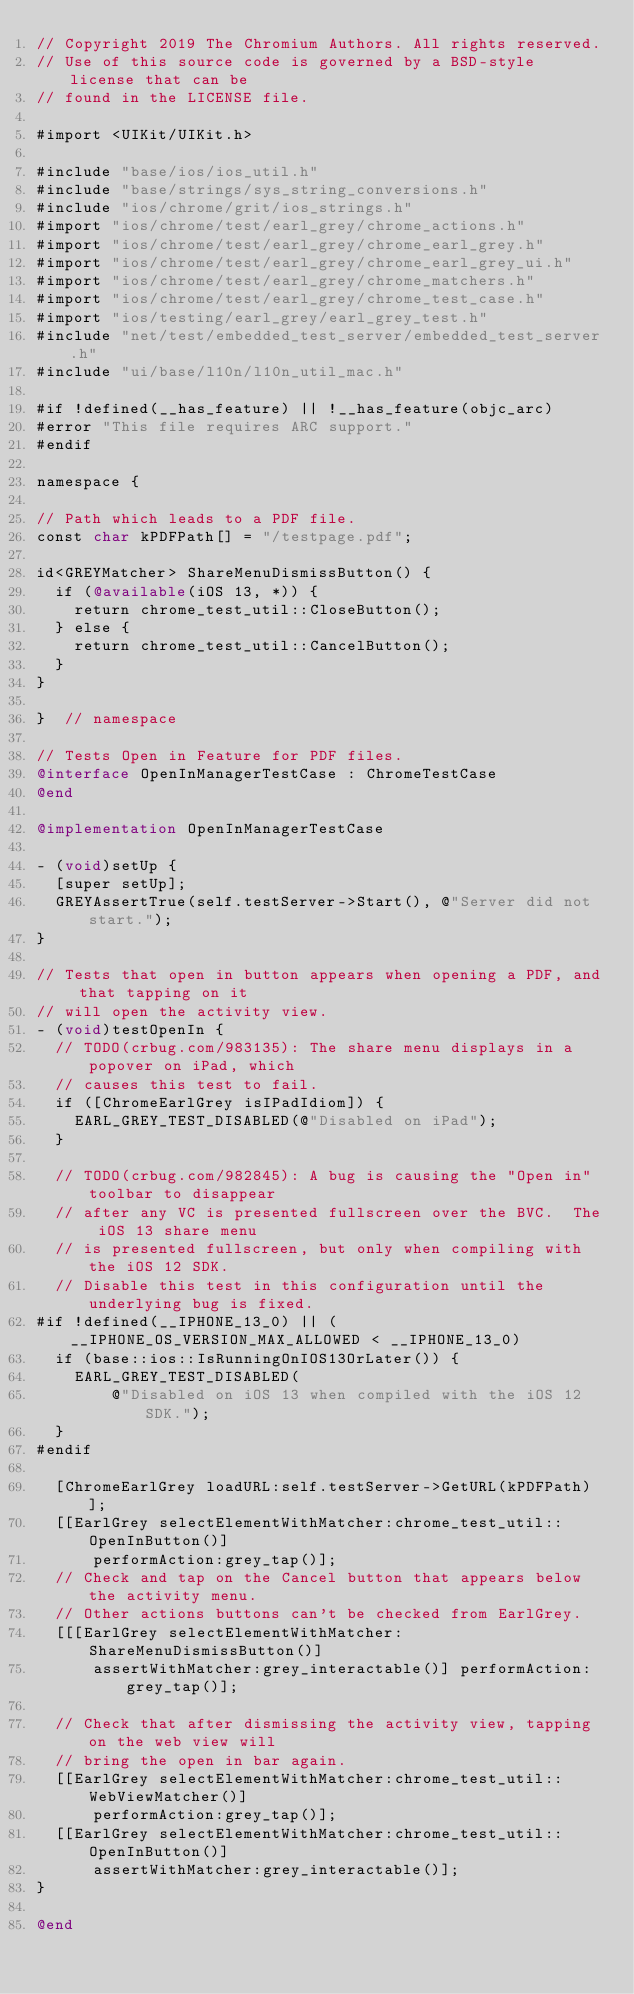Convert code to text. <code><loc_0><loc_0><loc_500><loc_500><_ObjectiveC_>// Copyright 2019 The Chromium Authors. All rights reserved.
// Use of this source code is governed by a BSD-style license that can be
// found in the LICENSE file.

#import <UIKit/UIKit.h>

#include "base/ios/ios_util.h"
#include "base/strings/sys_string_conversions.h"
#include "ios/chrome/grit/ios_strings.h"
#import "ios/chrome/test/earl_grey/chrome_actions.h"
#import "ios/chrome/test/earl_grey/chrome_earl_grey.h"
#import "ios/chrome/test/earl_grey/chrome_earl_grey_ui.h"
#import "ios/chrome/test/earl_grey/chrome_matchers.h"
#import "ios/chrome/test/earl_grey/chrome_test_case.h"
#import "ios/testing/earl_grey/earl_grey_test.h"
#include "net/test/embedded_test_server/embedded_test_server.h"
#include "ui/base/l10n/l10n_util_mac.h"

#if !defined(__has_feature) || !__has_feature(objc_arc)
#error "This file requires ARC support."
#endif

namespace {

// Path which leads to a PDF file.
const char kPDFPath[] = "/testpage.pdf";

id<GREYMatcher> ShareMenuDismissButton() {
  if (@available(iOS 13, *)) {
    return chrome_test_util::CloseButton();
  } else {
    return chrome_test_util::CancelButton();
  }
}

}  // namespace

// Tests Open in Feature for PDF files.
@interface OpenInManagerTestCase : ChromeTestCase
@end

@implementation OpenInManagerTestCase

- (void)setUp {
  [super setUp];
  GREYAssertTrue(self.testServer->Start(), @"Server did not start.");
}

// Tests that open in button appears when opening a PDF, and that tapping on it
// will open the activity view.
- (void)testOpenIn {
  // TODO(crbug.com/983135): The share menu displays in a popover on iPad, which
  // causes this test to fail.
  if ([ChromeEarlGrey isIPadIdiom]) {
    EARL_GREY_TEST_DISABLED(@"Disabled on iPad");
  }

  // TODO(crbug.com/982845): A bug is causing the "Open in" toolbar to disappear
  // after any VC is presented fullscreen over the BVC.  The iOS 13 share menu
  // is presented fullscreen, but only when compiling with the iOS 12 SDK.
  // Disable this test in this configuration until the underlying bug is fixed.
#if !defined(__IPHONE_13_0) || (__IPHONE_OS_VERSION_MAX_ALLOWED < __IPHONE_13_0)
  if (base::ios::IsRunningOnIOS13OrLater()) {
    EARL_GREY_TEST_DISABLED(
        @"Disabled on iOS 13 when compiled with the iOS 12 SDK.");
  }
#endif

  [ChromeEarlGrey loadURL:self.testServer->GetURL(kPDFPath)];
  [[EarlGrey selectElementWithMatcher:chrome_test_util::OpenInButton()]
      performAction:grey_tap()];
  // Check and tap on the Cancel button that appears below the activity menu.
  // Other actions buttons can't be checked from EarlGrey.
  [[[EarlGrey selectElementWithMatcher:ShareMenuDismissButton()]
      assertWithMatcher:grey_interactable()] performAction:grey_tap()];

  // Check that after dismissing the activity view, tapping on the web view will
  // bring the open in bar again.
  [[EarlGrey selectElementWithMatcher:chrome_test_util::WebViewMatcher()]
      performAction:grey_tap()];
  [[EarlGrey selectElementWithMatcher:chrome_test_util::OpenInButton()]
      assertWithMatcher:grey_interactable()];
}

@end
</code> 